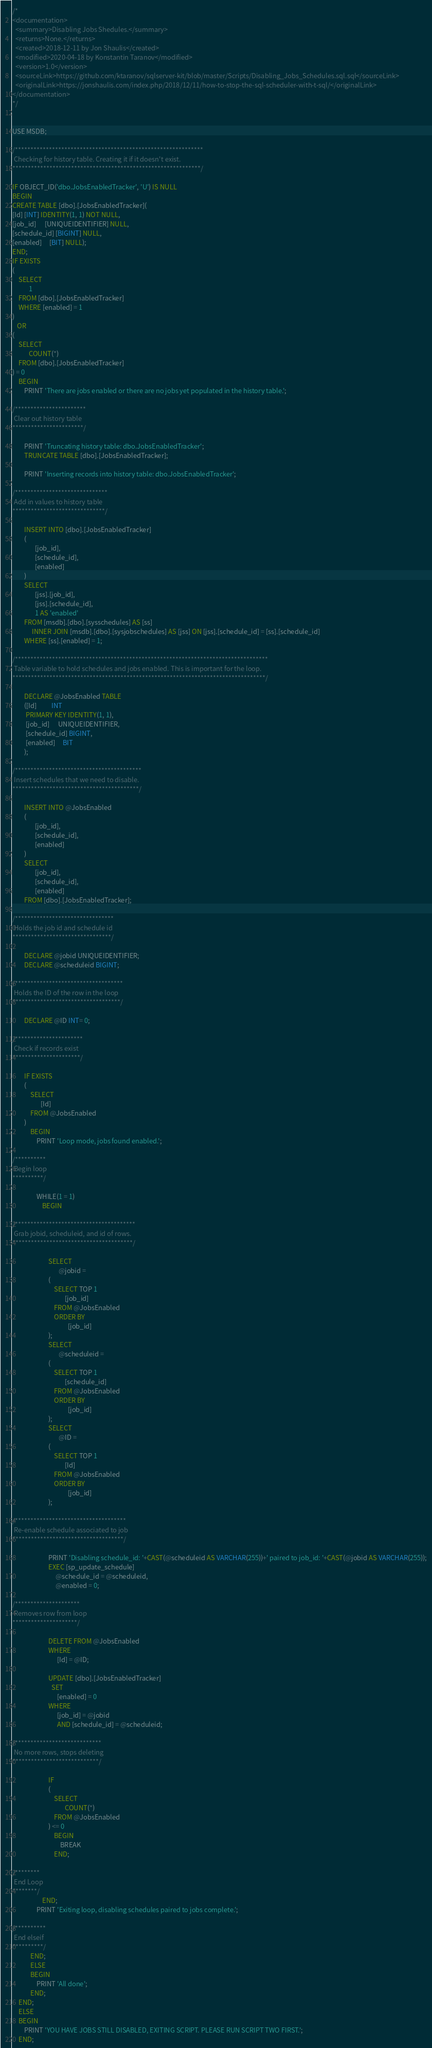Convert code to text. <code><loc_0><loc_0><loc_500><loc_500><_SQL_>/*
<documentation>
  <summary>Disabling Jobs Shedules.</summary>
  <returns>None.</returns>
  <created>2018-12-11 by Jon Shaulis</created>
  <modified>2020-04-18 by Konstantin Taranov</modified>
  <version>1.0</version>
  <sourceLink>https://github.com/ktaranov/sqlserver-kit/blob/master/Scripts/Disabling_Jobs_Schedules.sql.sql</sourceLink>
  <originalLink>https://jonshaulis.com/index.php/2018/12/11/how-to-stop-the-sql-scheduler-with-t-sql/</originalLink>
</documentation>
*/


USE MSDB;

/*************************************************************
 Checking for history table. Creating it if it doesn't exist. 
*************************************************************/

IF OBJECT_ID('dbo.JobsEnabledTracker', 'U') IS NULL
BEGIN
CREATE TABLE [dbo].[JobsEnabledTracker](
[Id] [INT] IDENTITY(1, 1) NOT NULL, 
[job_id]      [UNIQUEIDENTIFIER] NULL, 
[schedule_id] [BIGINT] NULL, 
[enabled]     [BIT] NULL);
END;
IF EXISTS
(
    SELECT 
           1
    FROM [dbo].[JobsEnabledTracker]
    WHERE [enabled] = 1
)
   OR
(
    SELECT 
           COUNT(*)
    FROM [dbo].[JobsEnabledTracker]
) = 0
    BEGIN
        PRINT 'There are jobs enabled or there are no jobs yet populated in the history table.';

/***********************
 Clear out history table
***********************/

        PRINT 'Truncating history table: dbo.JobsEnabledTracker';
        TRUNCATE TABLE [dbo].[JobsEnabledTracker];

        PRINT 'Inserting records into history table: dbo.JobsEnabledTracker';

/******************************
 Add in values to history table
******************************/

        INSERT INTO [dbo].[JobsEnabledTracker]
        (
               [job_id], 
               [schedule_id], 
               [enabled]
        )
        SELECT 
               [jss].[job_id], 
               [jss].[schedule_id], 
               1 AS 'enabled'
        FROM [msdb].[dbo].[sysschedules] AS [ss]
             INNER JOIN [msdb].[dbo].[sysjobschedules] AS [jss] ON [jss].[schedule_id] = [ss].[schedule_id]
        WHERE [ss].[enabled] = 1;

/**********************************************************************************
 Table variable to hold schedules and jobs enabled. This is important for the loop.
**********************************************************************************/

        DECLARE @JobsEnabled TABLE
        ([Id]          INT
         PRIMARY KEY IDENTITY(1, 1), 
         [job_id]      UNIQUEIDENTIFIER, 
         [schedule_id] BIGINT, 
         [enabled]     BIT
        );

/*****************************************
 Insert schedules that we need to disable.
*****************************************/

        INSERT INTO @JobsEnabled
        (
               [job_id], 
               [schedule_id], 
               [enabled]
        )
        SELECT 
               [job_id], 
               [schedule_id], 
               [enabled]
        FROM [dbo].[JobsEnabledTracker];

/********************************
 Holds the job id and schedule id
********************************/

        DECLARE @jobid UNIQUEIDENTIFIER;
        DECLARE @scheduleid BIGINT;

/***********************************
 Holds the ID of the row in the loop
***********************************/

        DECLARE @ID INT= 0;

/**********************
 Check if records exist
**********************/

        IF EXISTS
        (
            SELECT 
                   [Id]
            FROM @JobsEnabled
        )
            BEGIN
                PRINT 'Loop mode, jobs found enabled.';

/**********
 Begin loop
**********/

                WHILE(1 = 1)
                    BEGIN

/***************************************
 Grab jobid, scheduleid, and id of rows.
***************************************/

                        SELECT 
                               @jobid =
                        (
                            SELECT TOP 1 
                                   [job_id]
                            FROM @JobsEnabled
                            ORDER BY 
                                     [job_id]
                        );
                        SELECT 
                               @scheduleid =
                        (
                            SELECT TOP 1 
                                   [schedule_id]
                            FROM @JobsEnabled
                            ORDER BY 
                                     [job_id]
                        );
                        SELECT 
                               @ID =
                        (
                            SELECT TOP 1 
                                   [Id]
                            FROM @JobsEnabled
                            ORDER BY 
                                     [job_id]
                        );

/************************************
 Re-enable schedule associated to job
************************************/

                        PRINT 'Disabling schedule_id: '+CAST(@scheduleid AS VARCHAR(255))+' paired to job_id: '+CAST(@jobid AS VARCHAR(255));
                        EXEC [sp_update_schedule] 
                             @schedule_id = @scheduleid, 
                             @enabled = 0;

/*********************
 Removes row from loop
*********************/

                        DELETE FROM @JobsEnabled
                        WHERE 
                              [Id] = @ID;

                        UPDATE [dbo].[JobsEnabledTracker]
                          SET 
                              [enabled] = 0
                        WHERE 
                              [job_id] = @jobid
                              AND [schedule_id] = @scheduleid;

/****************************
 No more rows, stops deleting
****************************/

                        IF
                        (
                            SELECT 
                                   COUNT(*)
                            FROM @JobsEnabled
                        ) <= 0
                            BEGIN
                                BREAK
                            END;

/********
 End Loop
********/
                    END;
                PRINT 'Exiting loop, disabling schedules paired to jobs complete.';

/**********
 End elseif
**********/
            END;
            ELSE
            BEGIN
                PRINT 'All done';
            END;
    END;
    ELSE
    BEGIN
        PRINT 'YOU HAVE JOBS STILL DISABLED, EXITING SCRIPT. PLEASE RUN SCRIPT TWO FIRST.';
    END;
</code> 